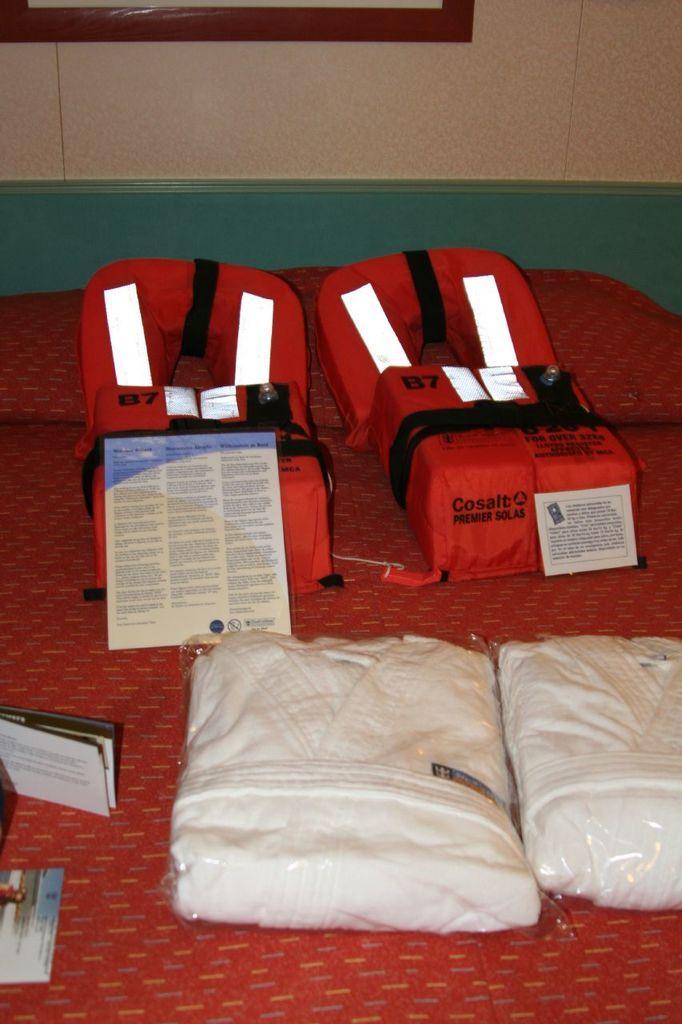Can you describe this image briefly? The picture is taken in a room. In this picture there is a bed, on the bed there are life jackets, clothes, pamphlets and other objects. At the top there is a frame attached to the wall. 